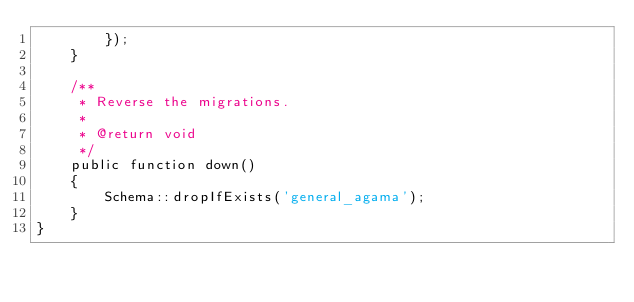Convert code to text. <code><loc_0><loc_0><loc_500><loc_500><_PHP_>        });
    }

    /**
     * Reverse the migrations.
     *
     * @return void
     */
    public function down()
    {
        Schema::dropIfExists('general_agama');
    }
}
</code> 